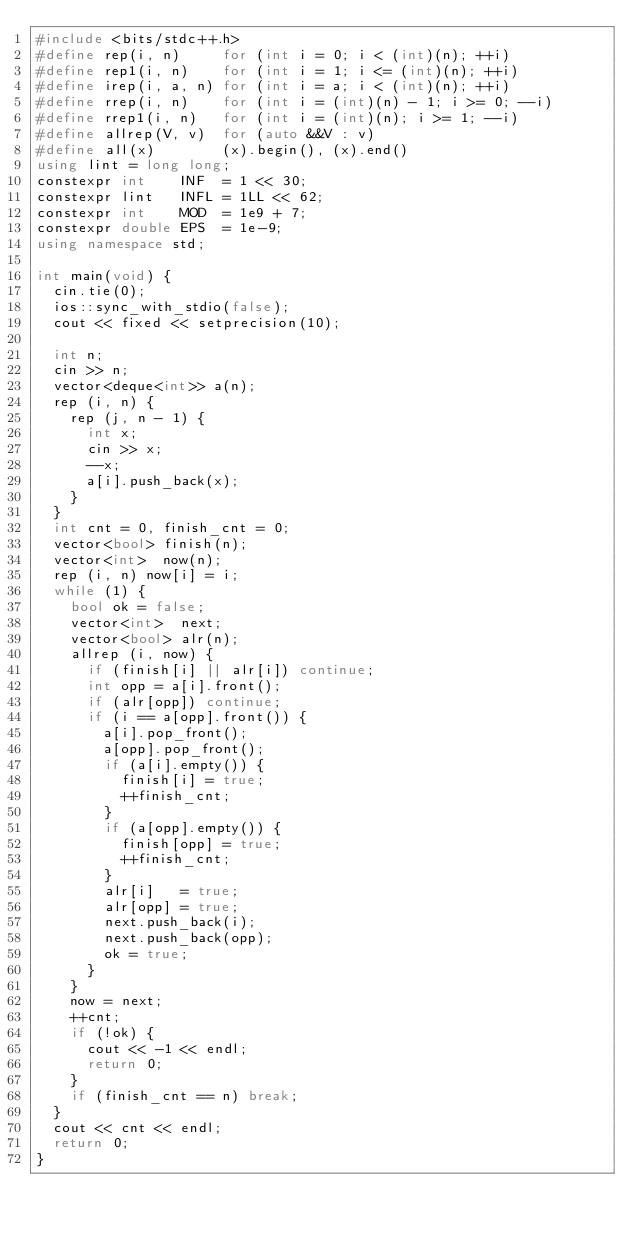Convert code to text. <code><loc_0><loc_0><loc_500><loc_500><_C++_>#include <bits/stdc++.h>
#define rep(i, n)     for (int i = 0; i < (int)(n); ++i)
#define rep1(i, n)    for (int i = 1; i <= (int)(n); ++i)
#define irep(i, a, n) for (int i = a; i < (int)(n); ++i)
#define rrep(i, n)    for (int i = (int)(n) - 1; i >= 0; --i)
#define rrep1(i, n)   for (int i = (int)(n); i >= 1; --i)
#define allrep(V, v)  for (auto &&V : v)
#define all(x)        (x).begin(), (x).end()
using lint = long long;
constexpr int    INF  = 1 << 30;
constexpr lint   INFL = 1LL << 62;
constexpr int    MOD  = 1e9 + 7;
constexpr double EPS  = 1e-9;
using namespace std;

int main(void) {
  cin.tie(0);
  ios::sync_with_stdio(false);
  cout << fixed << setprecision(10);

  int n;
  cin >> n;
  vector<deque<int>> a(n);
  rep (i, n) {
    rep (j, n - 1) {
      int x;
      cin >> x;
      --x;
      a[i].push_back(x);
    }
  }
  int cnt = 0, finish_cnt = 0;
  vector<bool> finish(n);
  vector<int>  now(n);
  rep (i, n) now[i] = i;
  while (1) {
    bool ok = false;
    vector<int>  next;
    vector<bool> alr(n);
    allrep (i, now) {
      if (finish[i] || alr[i]) continue;
      int opp = a[i].front();
      if (alr[opp]) continue;
      if (i == a[opp].front()) {
        a[i].pop_front();
        a[opp].pop_front();
        if (a[i].empty()) {
          finish[i] = true;
          ++finish_cnt;
        }
        if (a[opp].empty()) {
          finish[opp] = true;
          ++finish_cnt;
        }
        alr[i]   = true;
        alr[opp] = true;
        next.push_back(i);
        next.push_back(opp);
        ok = true;
      }
    }
    now = next;
    ++cnt;
    if (!ok) {
      cout << -1 << endl;
      return 0;
    }
    if (finish_cnt == n) break;
  }
  cout << cnt << endl;
  return 0;
}</code> 